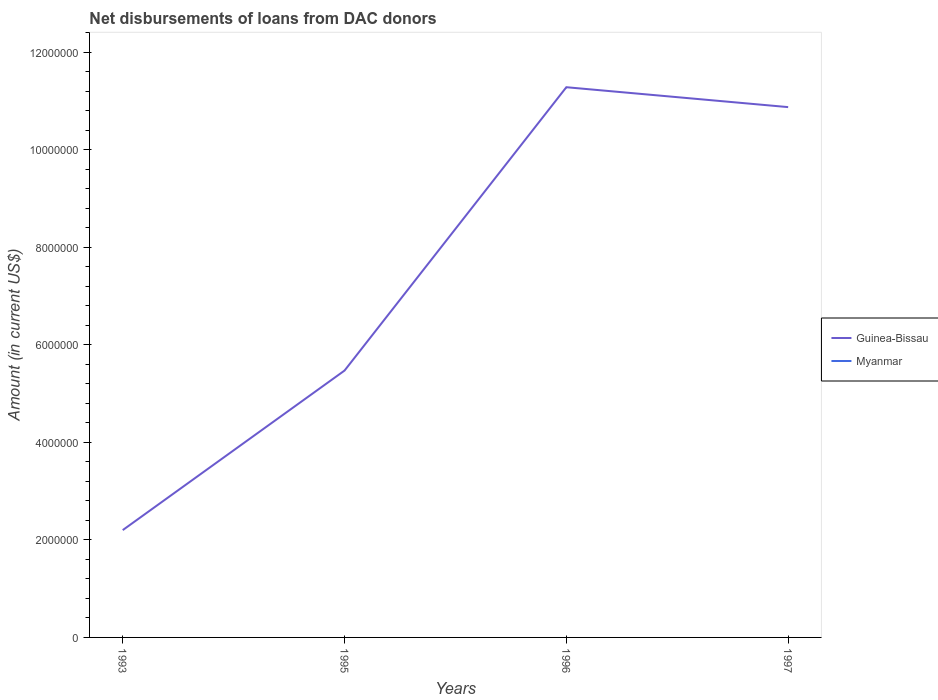Is the number of lines equal to the number of legend labels?
Your answer should be compact. No. Across all years, what is the maximum amount of loans disbursed in Guinea-Bissau?
Your answer should be compact. 2.20e+06. What is the total amount of loans disbursed in Guinea-Bissau in the graph?
Your answer should be very brief. 4.08e+05. What is the difference between the highest and the second highest amount of loans disbursed in Guinea-Bissau?
Your answer should be very brief. 9.08e+06. What is the difference between the highest and the lowest amount of loans disbursed in Myanmar?
Offer a terse response. 0. How many lines are there?
Ensure brevity in your answer.  1. How many years are there in the graph?
Your answer should be very brief. 4. What is the difference between two consecutive major ticks on the Y-axis?
Make the answer very short. 2.00e+06. Are the values on the major ticks of Y-axis written in scientific E-notation?
Make the answer very short. No. Does the graph contain any zero values?
Ensure brevity in your answer.  Yes. Where does the legend appear in the graph?
Your response must be concise. Center right. How many legend labels are there?
Provide a short and direct response. 2. What is the title of the graph?
Your answer should be compact. Net disbursements of loans from DAC donors. What is the label or title of the Y-axis?
Provide a short and direct response. Amount (in current US$). What is the Amount (in current US$) in Guinea-Bissau in 1993?
Keep it short and to the point. 2.20e+06. What is the Amount (in current US$) in Guinea-Bissau in 1995?
Offer a terse response. 5.47e+06. What is the Amount (in current US$) in Myanmar in 1995?
Give a very brief answer. 0. What is the Amount (in current US$) of Guinea-Bissau in 1996?
Offer a terse response. 1.13e+07. What is the Amount (in current US$) in Guinea-Bissau in 1997?
Offer a terse response. 1.09e+07. Across all years, what is the maximum Amount (in current US$) in Guinea-Bissau?
Give a very brief answer. 1.13e+07. Across all years, what is the minimum Amount (in current US$) in Guinea-Bissau?
Your answer should be very brief. 2.20e+06. What is the total Amount (in current US$) in Guinea-Bissau in the graph?
Ensure brevity in your answer.  2.98e+07. What is the difference between the Amount (in current US$) of Guinea-Bissau in 1993 and that in 1995?
Offer a very short reply. -3.27e+06. What is the difference between the Amount (in current US$) of Guinea-Bissau in 1993 and that in 1996?
Keep it short and to the point. -9.08e+06. What is the difference between the Amount (in current US$) of Guinea-Bissau in 1993 and that in 1997?
Provide a succinct answer. -8.67e+06. What is the difference between the Amount (in current US$) of Guinea-Bissau in 1995 and that in 1996?
Your answer should be very brief. -5.81e+06. What is the difference between the Amount (in current US$) in Guinea-Bissau in 1995 and that in 1997?
Offer a terse response. -5.40e+06. What is the difference between the Amount (in current US$) of Guinea-Bissau in 1996 and that in 1997?
Provide a short and direct response. 4.08e+05. What is the average Amount (in current US$) in Guinea-Bissau per year?
Make the answer very short. 7.46e+06. What is the average Amount (in current US$) of Myanmar per year?
Provide a succinct answer. 0. What is the ratio of the Amount (in current US$) of Guinea-Bissau in 1993 to that in 1995?
Your answer should be very brief. 0.4. What is the ratio of the Amount (in current US$) in Guinea-Bissau in 1993 to that in 1996?
Your answer should be compact. 0.2. What is the ratio of the Amount (in current US$) in Guinea-Bissau in 1993 to that in 1997?
Provide a short and direct response. 0.2. What is the ratio of the Amount (in current US$) in Guinea-Bissau in 1995 to that in 1996?
Your answer should be very brief. 0.48. What is the ratio of the Amount (in current US$) in Guinea-Bissau in 1995 to that in 1997?
Make the answer very short. 0.5. What is the ratio of the Amount (in current US$) in Guinea-Bissau in 1996 to that in 1997?
Your answer should be very brief. 1.04. What is the difference between the highest and the second highest Amount (in current US$) of Guinea-Bissau?
Your answer should be very brief. 4.08e+05. What is the difference between the highest and the lowest Amount (in current US$) of Guinea-Bissau?
Keep it short and to the point. 9.08e+06. 